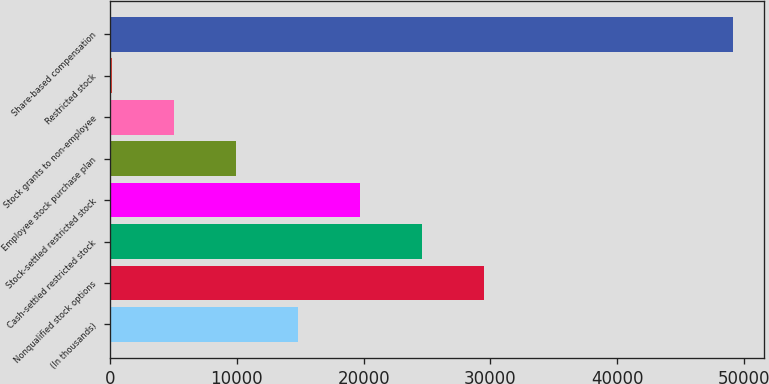Convert chart. <chart><loc_0><loc_0><loc_500><loc_500><bar_chart><fcel>(In thousands)<fcel>Nonqualified stock options<fcel>Cash-settled restricted stock<fcel>Stock-settled restricted stock<fcel>Employee stock purchase plan<fcel>Stock grants to non-employee<fcel>Restricted stock<fcel>Share-based compensation<nl><fcel>14845.3<fcel>29527.6<fcel>24633.5<fcel>19739.4<fcel>9951.2<fcel>5057.1<fcel>163<fcel>49104<nl></chart> 